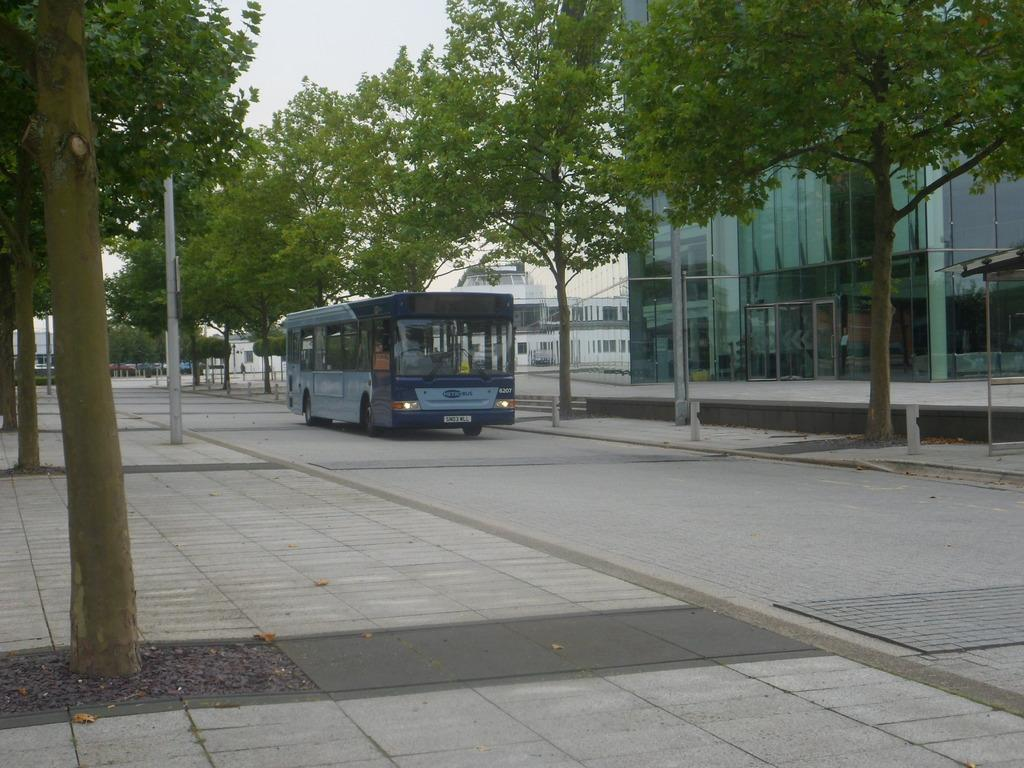What type of vehicle is on the road in the image? There is a bus on the road in the image. Can you describe the interior of the bus? A person is seated in the bus, indicating that there are seats inside. What can be seen beside the bus? There are poles and trees beside the bus. What is visible in the background of the image? There are buildings visible in the background of the image. What type of texture can be seen on the squirrel's fur in the image? There is no squirrel present in the image, so it is not possible to describe the texture of its fur. 